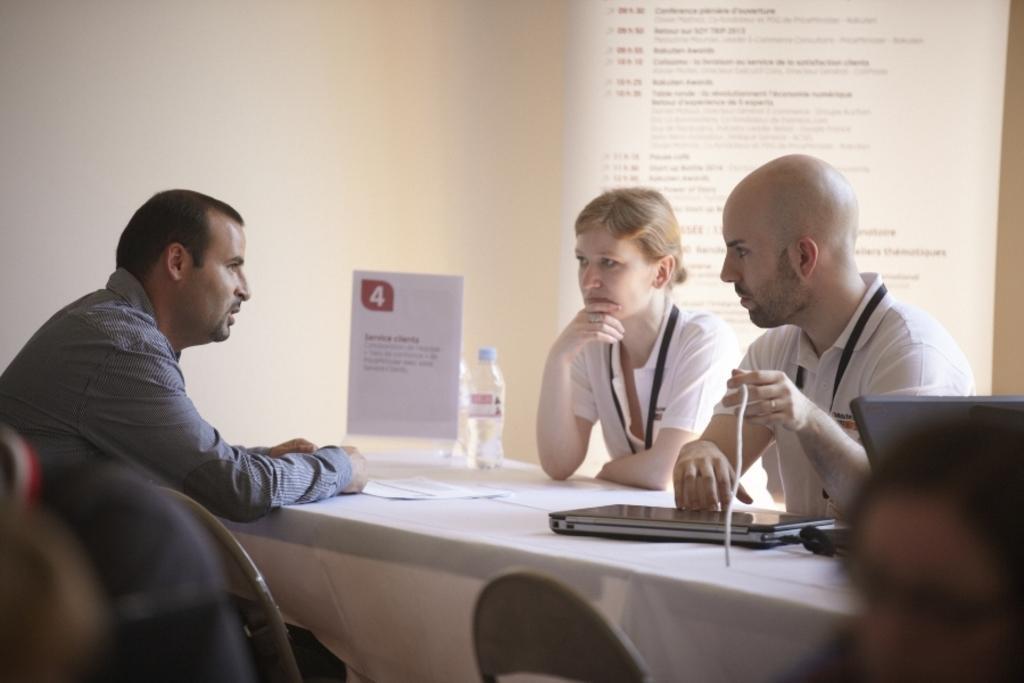Could you give a brief overview of what you see in this image? In the image we can see there are people sitting on the chair and on the table there is a laptop, water bottle and a menu card. Behind there is a projector screen on the wall. 